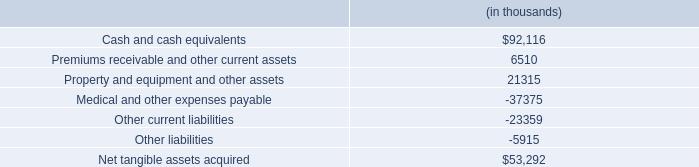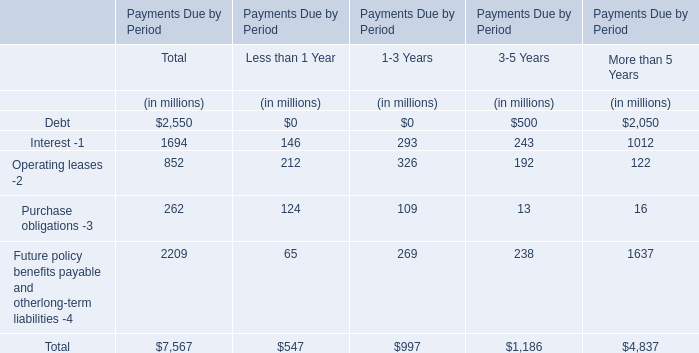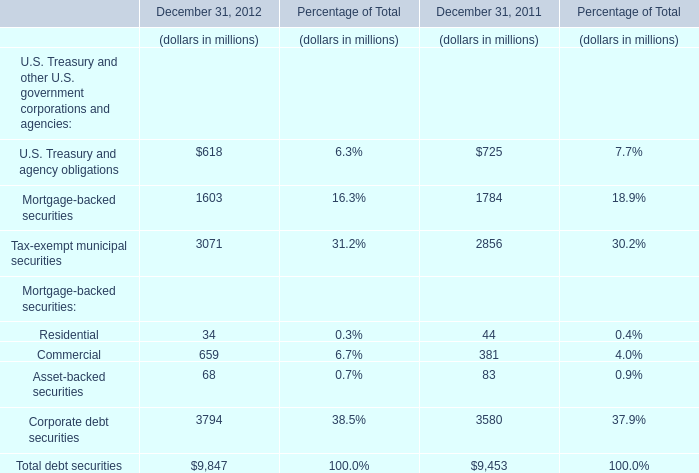what is the total value of assets , in thousands? 
Computations: ((6510 + 92116) + 21315)
Answer: 119941.0. 